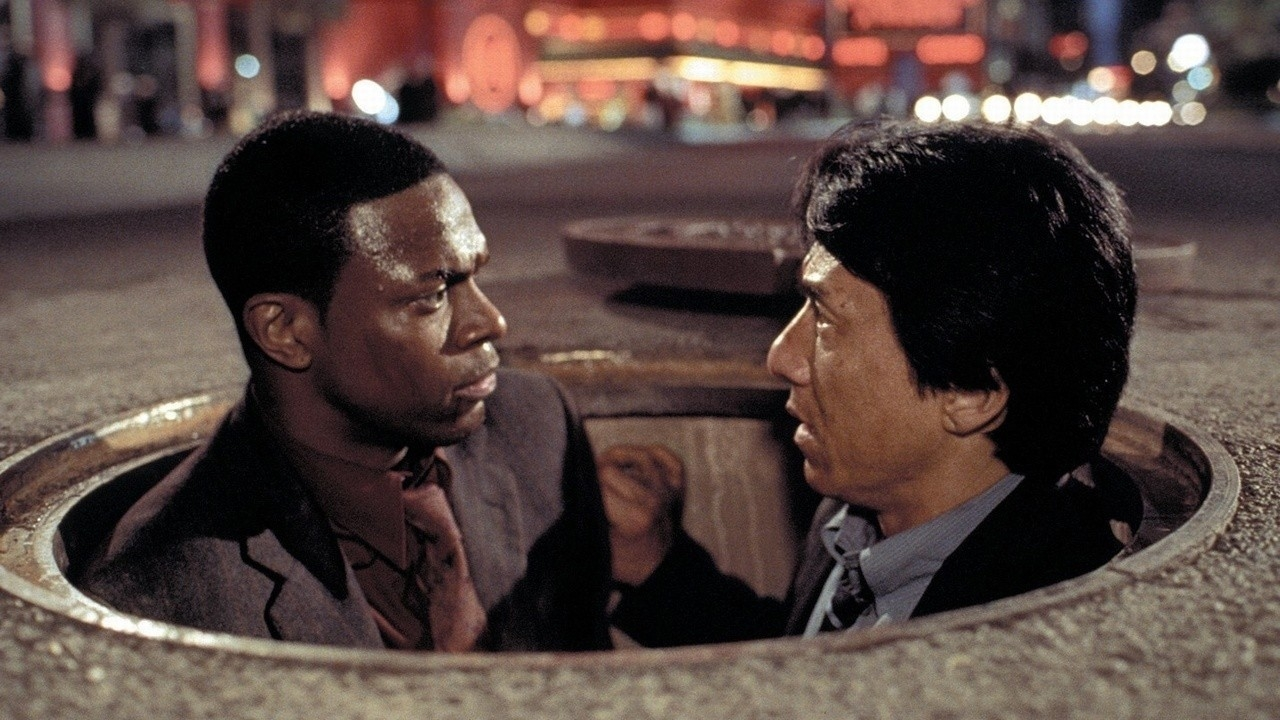What if this scene took place in a fantasy world? How would it change? In a fantasy world, this scene would take on a completely different dimension. Instead of a city street, imagine the manhole being the entrance to an ancient, enchanted forest with bioluminescent plants lighting the way. Chris Tucker and Jackie Chan's characters might be dressed in magical armor, and their intense discussion could be about navigating through forests filled with mythical creatures and hidden traps. The red glow in the background could be emanating from a powerful, mystical artifact they need to find to save their world from an impending dark force. The scene would transform from an urban chase to an ethereal quest filled with magic and wonder. 